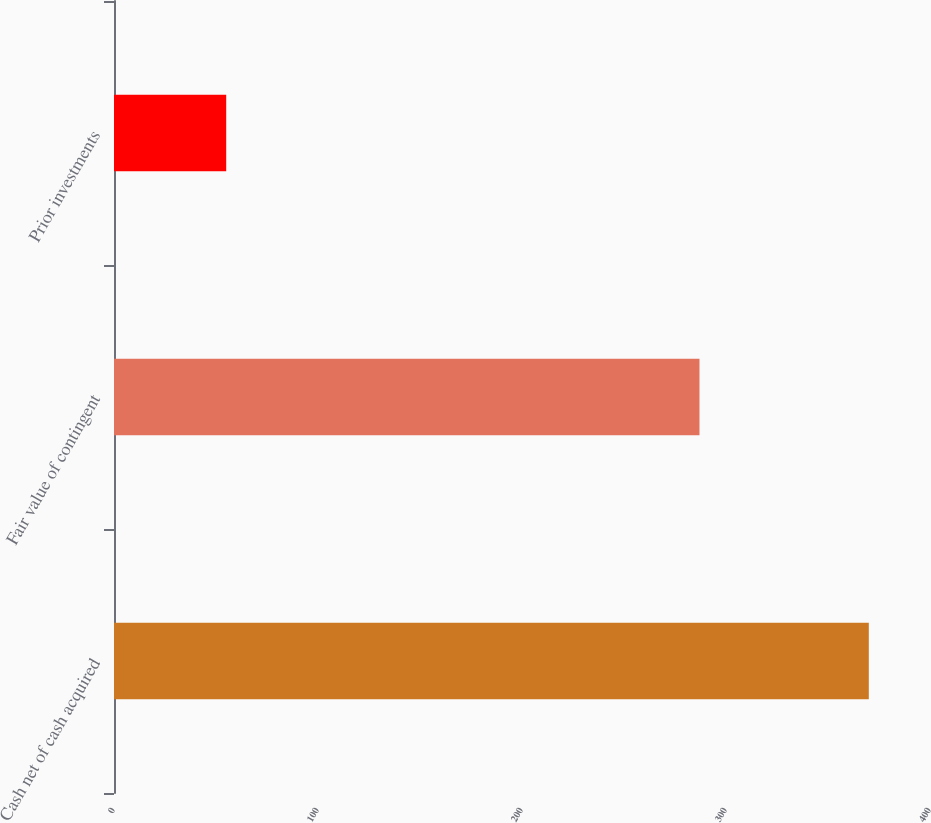Convert chart to OTSL. <chart><loc_0><loc_0><loc_500><loc_500><bar_chart><fcel>Cash net of cash acquired<fcel>Fair value of contingent<fcel>Prior investments<nl><fcel>370<fcel>287<fcel>55<nl></chart> 